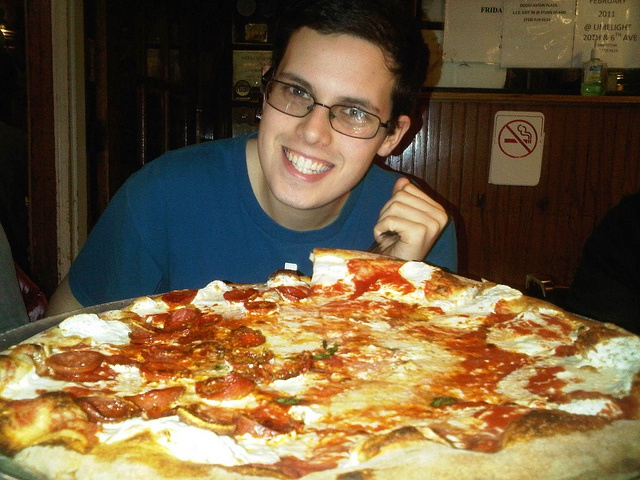Describe the objects in this image and their specific colors. I can see pizza in black, brown, khaki, ivory, and tan tones, people in black, darkblue, and tan tones, people in black and darkgreen tones, and bottle in black, darkgreen, and olive tones in this image. 